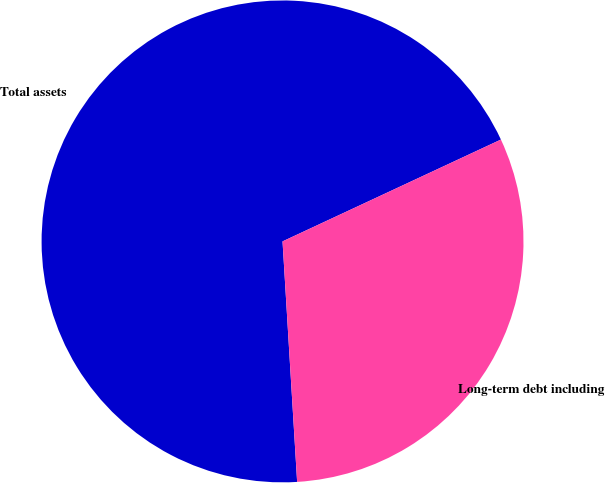Convert chart. <chart><loc_0><loc_0><loc_500><loc_500><pie_chart><fcel>Total assets<fcel>Long-term debt including<nl><fcel>69.02%<fcel>30.98%<nl></chart> 